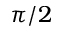Convert formula to latex. <formula><loc_0><loc_0><loc_500><loc_500>\pi / 2</formula> 